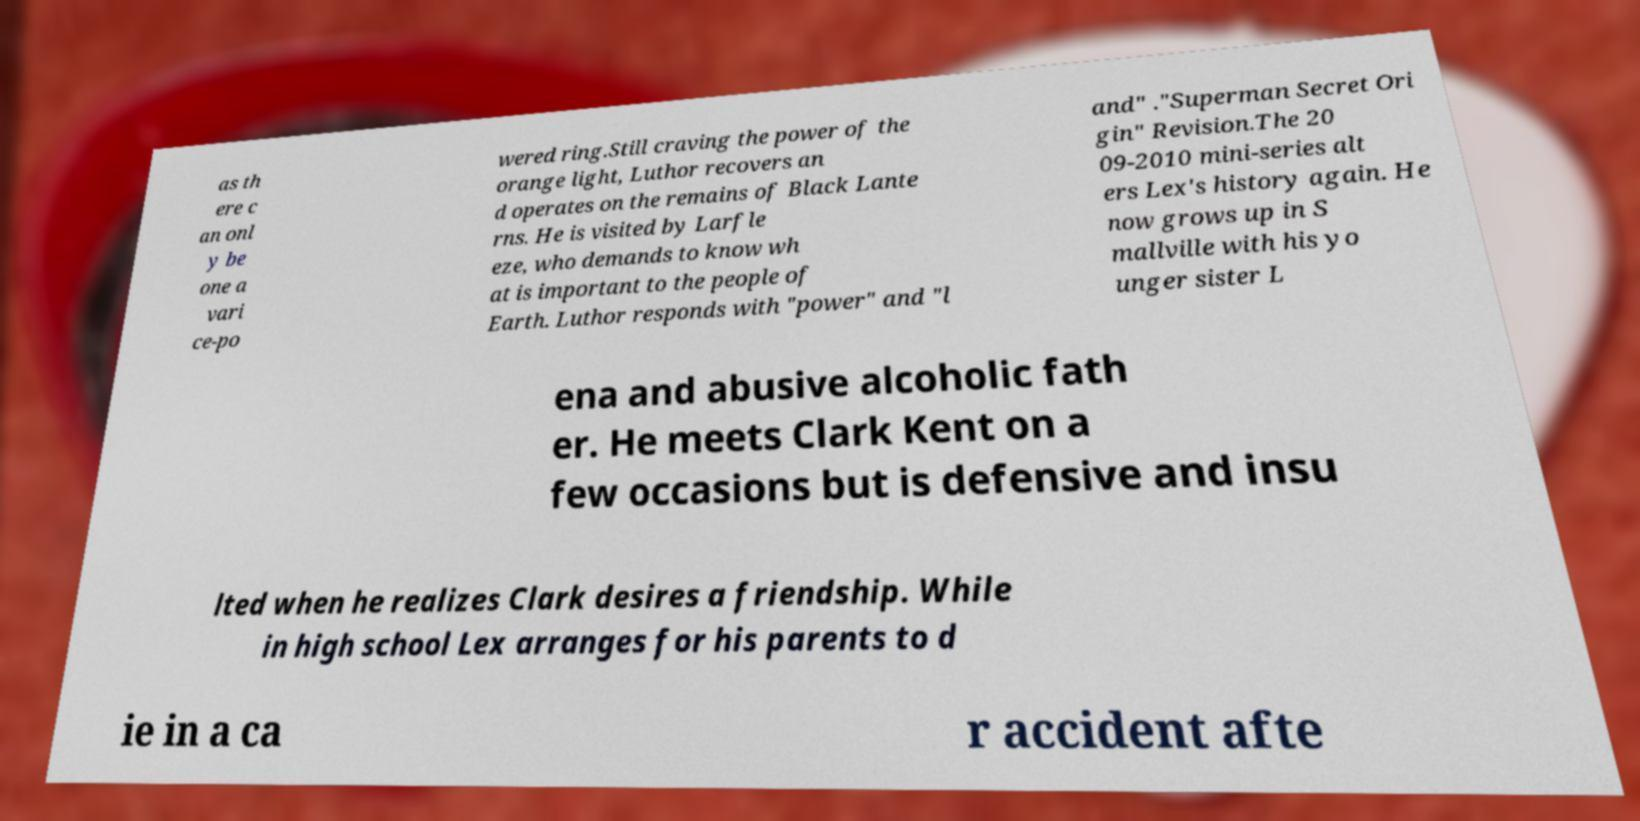I need the written content from this picture converted into text. Can you do that? as th ere c an onl y be one a vari ce-po wered ring.Still craving the power of the orange light, Luthor recovers an d operates on the remains of Black Lante rns. He is visited by Larfle eze, who demands to know wh at is important to the people of Earth. Luthor responds with "power" and "l and" ."Superman Secret Ori gin" Revision.The 20 09-2010 mini-series alt ers Lex's history again. He now grows up in S mallville with his yo unger sister L ena and abusive alcoholic fath er. He meets Clark Kent on a few occasions but is defensive and insu lted when he realizes Clark desires a friendship. While in high school Lex arranges for his parents to d ie in a ca r accident afte 